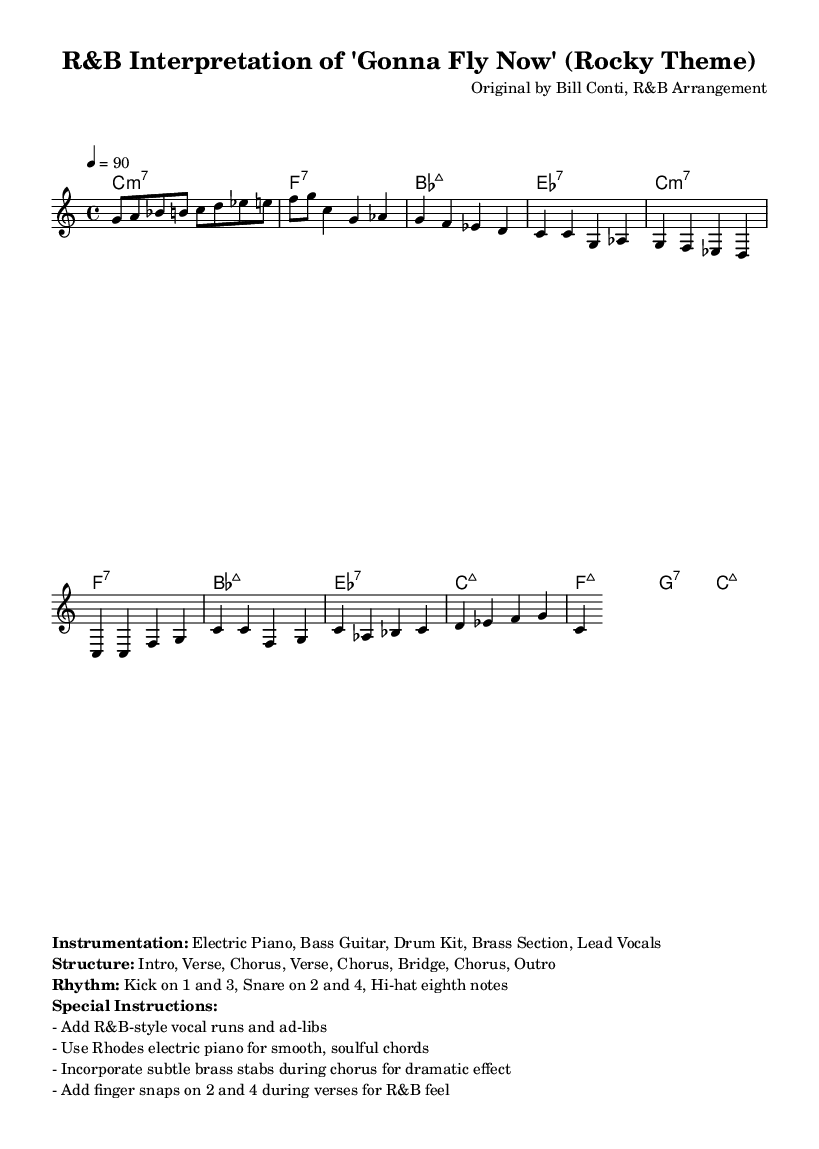What is the key signature of this music? The key signature is indicated at the beginning of the score under the clef symbol. It shows that there are no sharps or flats, which defines it as C major.
Answer: C major What is the time signature of this music? The time signature is present at the start of the sheet music, represented as 4/4, meaning there are four beats in each measure and the quarter note gets the beat.
Answer: 4/4 What is the tempo marking for this music? The tempo is given at the top of the score, indicating the speed at which the music should be played. In this case, it specifies 90 beats per minute.
Answer: 90 How many measures are there in the Chorus section? The Chorus section consists of two measures in the provided melody line and follows a specific pattern of chords that repeats in the same format.
Answer: 2 What type of piano is suggested for this arrangement? The special instructions included in the markup explicitly mention the use of a Rhodes electric piano, which is commonly used in Rhythm and Blues arrangements for its smooth sound.
Answer: Rhodes electric piano What special rhythmic elements are included in the verses? The special instructions identify finger snaps on beats 2 and 4 during the verses, which contributes to the characteristic R&B feel, emphasizing the groove of the rhythm.
Answer: Finger snaps on 2 and 4 What instruments are indicated for this arrangement? The instrumentation is listed in the markup section, which states that Electric Piano, Bass Guitar, Drum Kit, Brass Section, and Lead Vocals are included in the arrangement.
Answer: Electric Piano, Bass Guitar, Drum Kit, Brass Section, Lead Vocals 